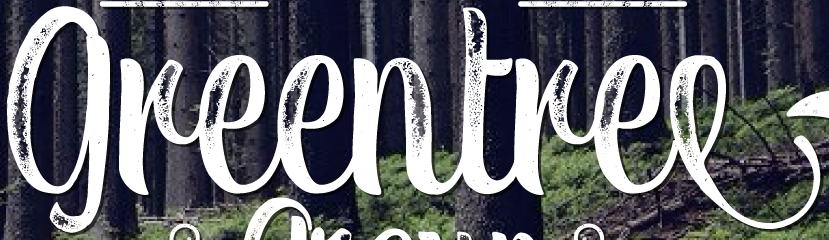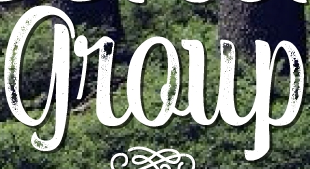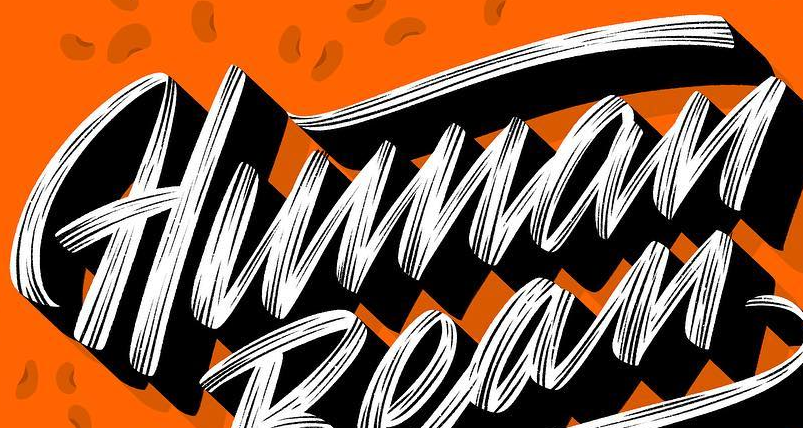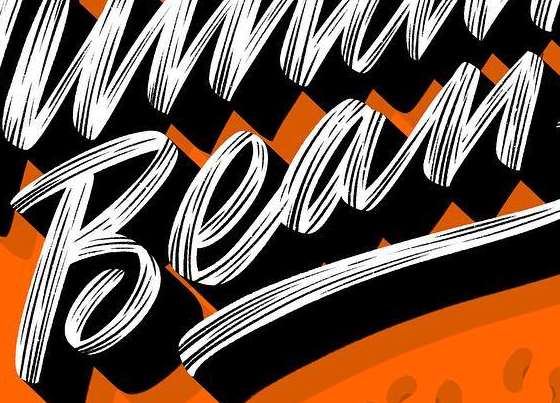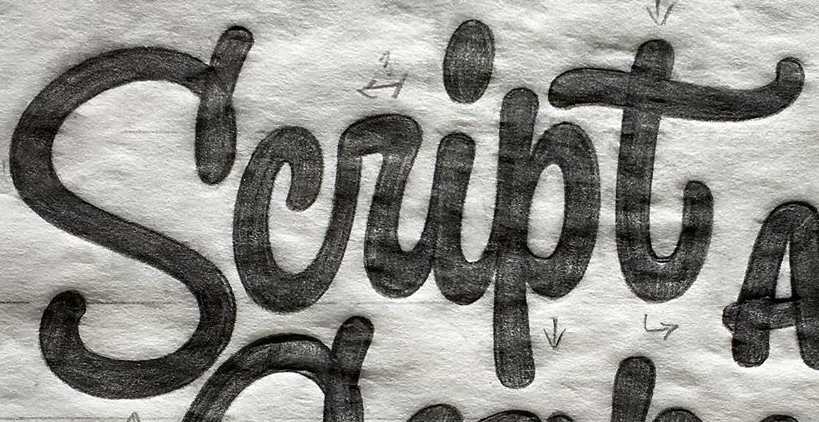What words are shown in these images in order, separated by a semicolon? greentree; group; Human; Bean; Script 